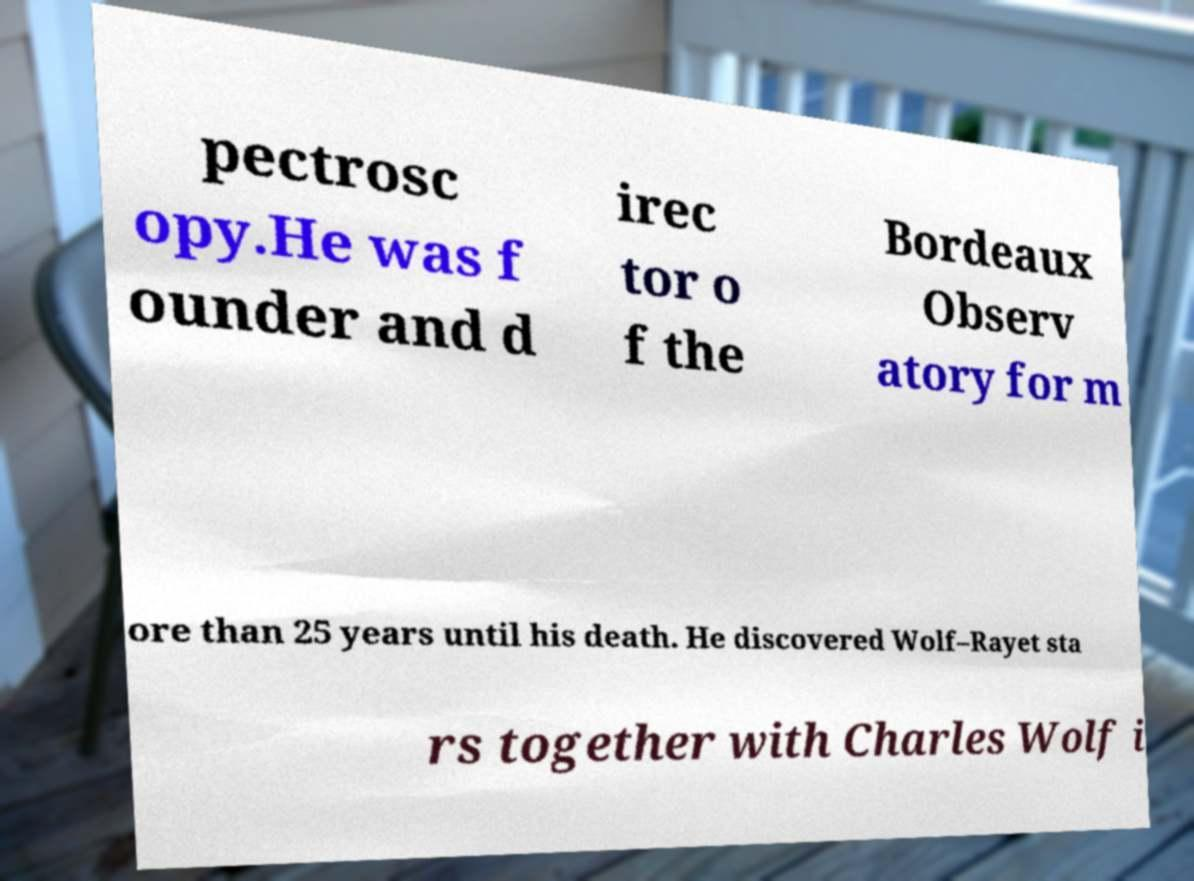Please read and relay the text visible in this image. What does it say? pectrosc opy.He was f ounder and d irec tor o f the Bordeaux Observ atory for m ore than 25 years until his death. He discovered Wolf–Rayet sta rs together with Charles Wolf i 